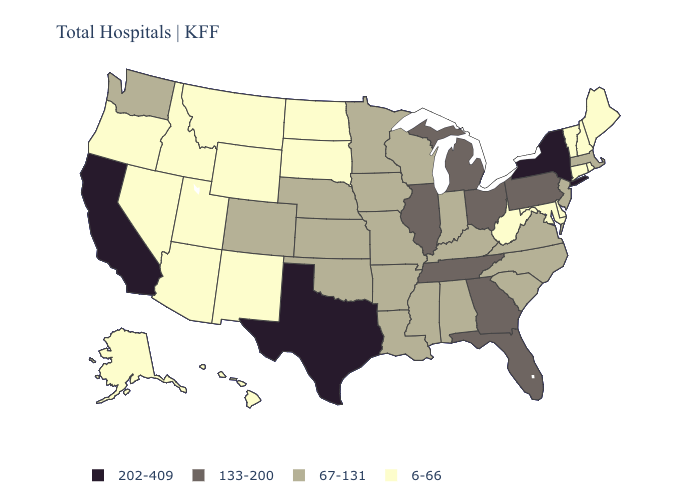Does Idaho have the highest value in the USA?
Give a very brief answer. No. Name the states that have a value in the range 133-200?
Keep it brief. Florida, Georgia, Illinois, Michigan, Ohio, Pennsylvania, Tennessee. What is the lowest value in the USA?
Concise answer only. 6-66. What is the lowest value in states that border Connecticut?
Short answer required. 6-66. Which states have the lowest value in the South?
Short answer required. Delaware, Maryland, West Virginia. Name the states that have a value in the range 67-131?
Be succinct. Alabama, Arkansas, Colorado, Indiana, Iowa, Kansas, Kentucky, Louisiana, Massachusetts, Minnesota, Mississippi, Missouri, Nebraska, New Jersey, North Carolina, Oklahoma, South Carolina, Virginia, Washington, Wisconsin. What is the value of Tennessee?
Keep it brief. 133-200. Name the states that have a value in the range 6-66?
Concise answer only. Alaska, Arizona, Connecticut, Delaware, Hawaii, Idaho, Maine, Maryland, Montana, Nevada, New Hampshire, New Mexico, North Dakota, Oregon, Rhode Island, South Dakota, Utah, Vermont, West Virginia, Wyoming. Does Minnesota have the lowest value in the MidWest?
Be succinct. No. What is the value of Wisconsin?
Concise answer only. 67-131. What is the highest value in states that border Kentucky?
Be succinct. 133-200. How many symbols are there in the legend?
Be succinct. 4. What is the value of Oklahoma?
Keep it brief. 67-131. Name the states that have a value in the range 133-200?
Write a very short answer. Florida, Georgia, Illinois, Michigan, Ohio, Pennsylvania, Tennessee. Among the states that border Florida , does Georgia have the highest value?
Give a very brief answer. Yes. 